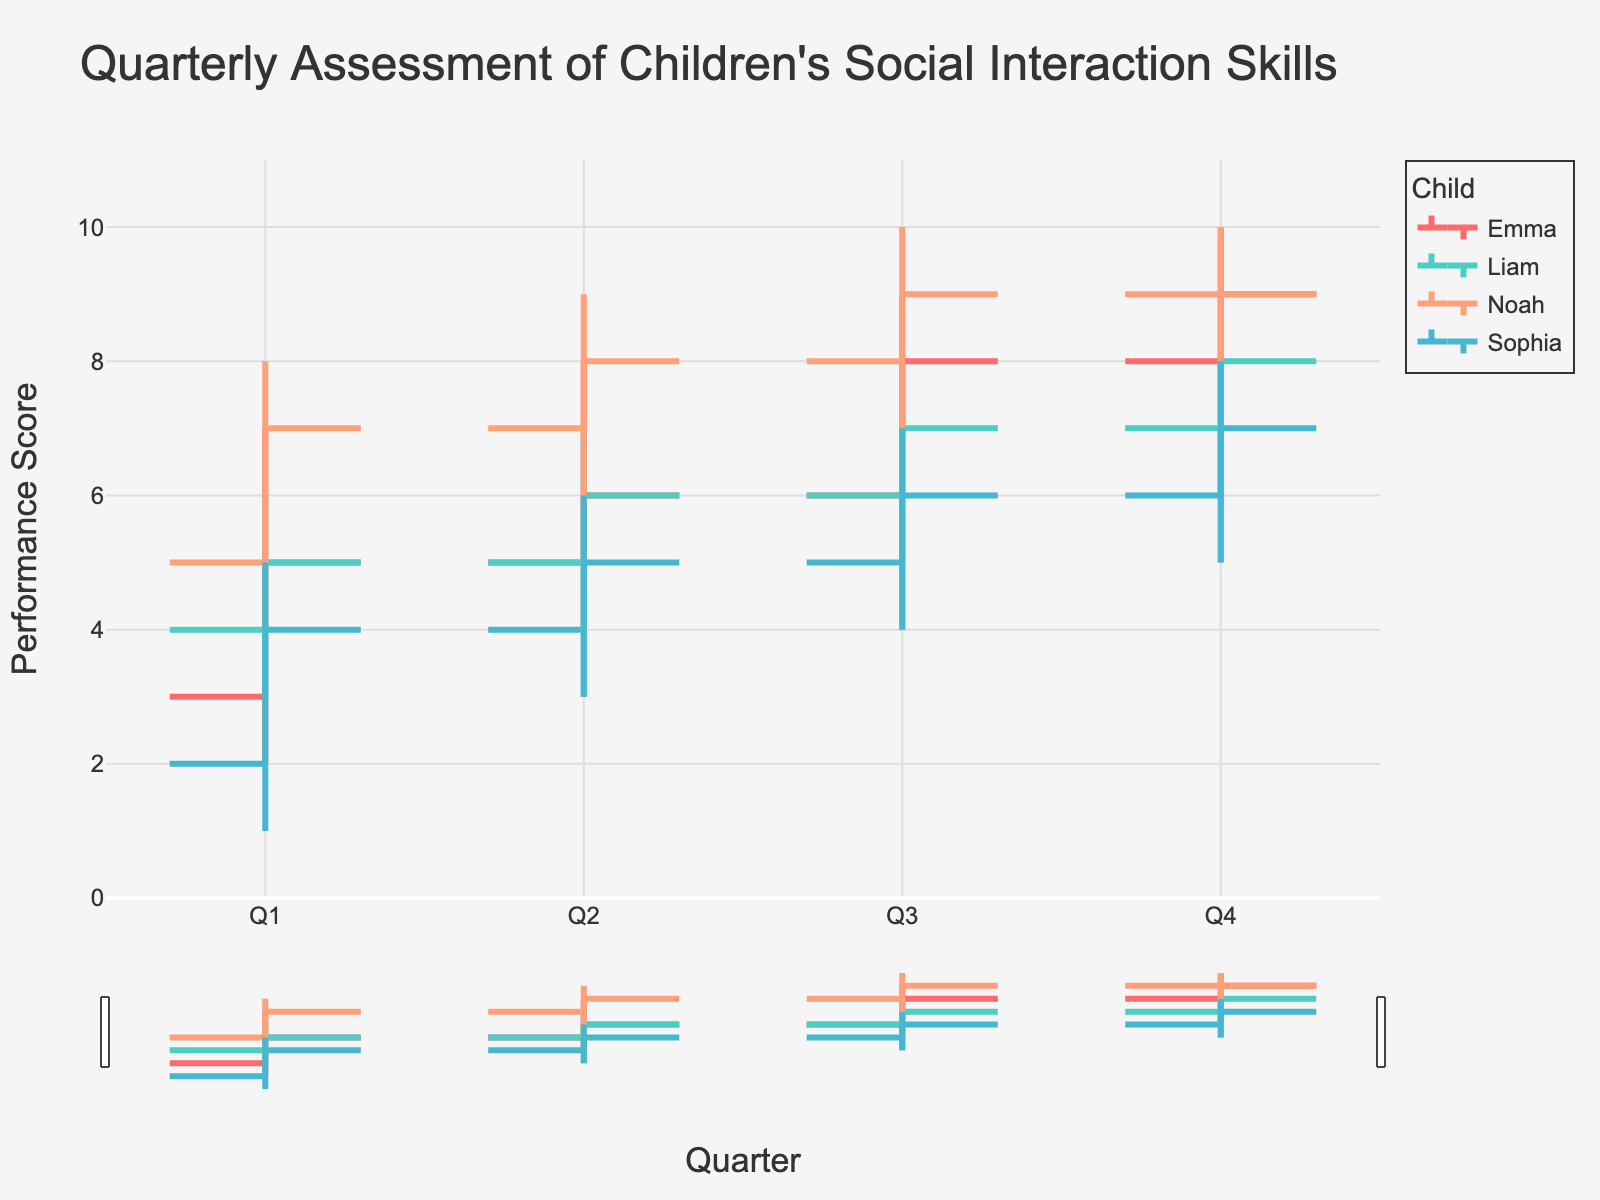What's the title of the figure? The title of the figure can be found at the top center of the plot.
Answer: Quarterly Assessment of Children's Social Interaction Skills Who has the highest closing performance in Q4? Locate the closing performance scores in Q4 for each child and identify the highest value.
Answer: Noah Which child's performance had the greatest increase from Q1 to Q4? Compare the closing performance scores of each child from Q1 to Q4 and find the one with the largest increase. Emma's performance increased from 5 to 9 (+4), Liam's from 5 to 8 (+3), Sophia's from 4 to 7 (+3), and Noah's from 7 to 9 (+2).
Answer: Emma How many children are represented in the figure? Check the legend or different colored lines in the figure to count the number of unique children.
Answer: Four What was the highest performance score reached by Emma in any quarter? Look for the highest (peak) performance score in Emma's data across all quarters.
Answer: 10 Between which quarters did Liam experience his lowest high performance score? Check for Liam's highest scores in each quarter and identify the lowest among those.
Answer: Q1 to Q2 Which child had the smallest range of performance scores in Q2? For each child in Q2, subtract the lowest score from the highest score to find the range, then compare these ranges. Emma's range: 8-4=4, Liam's range: 7-3=4, Sophia's range: 6-3=3, Noah's range: 9-5=4. Sophia has the smallest range.
Answer: Sophia Did Noah's performance ever decrease from one quarter to the next? Compare Noah’s closing performance scores sequentially from Q1 to Q4 to see if there’s any decrease. Noah's performance progressively increases or stays the same over time.
Answer: No What is the average high performance score of Sophia across all quarters? Calculate the average of Sophia's high scores: (5 + 6 + 7 + 8) / 4.
Answer: 6.5 Which two children had identical closing performance scores in Q1? Look at the closing performance scores in Q1 and find the identical values.
Answer: Emma and Liam 